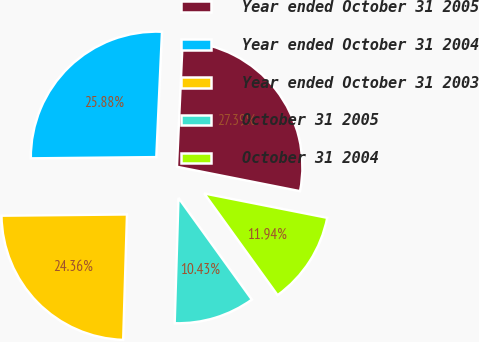Convert chart. <chart><loc_0><loc_0><loc_500><loc_500><pie_chart><fcel>Year ended October 31 2005<fcel>Year ended October 31 2004<fcel>Year ended October 31 2003<fcel>October 31 2005<fcel>October 31 2004<nl><fcel>27.39%<fcel>25.88%<fcel>24.36%<fcel>10.43%<fcel>11.94%<nl></chart> 